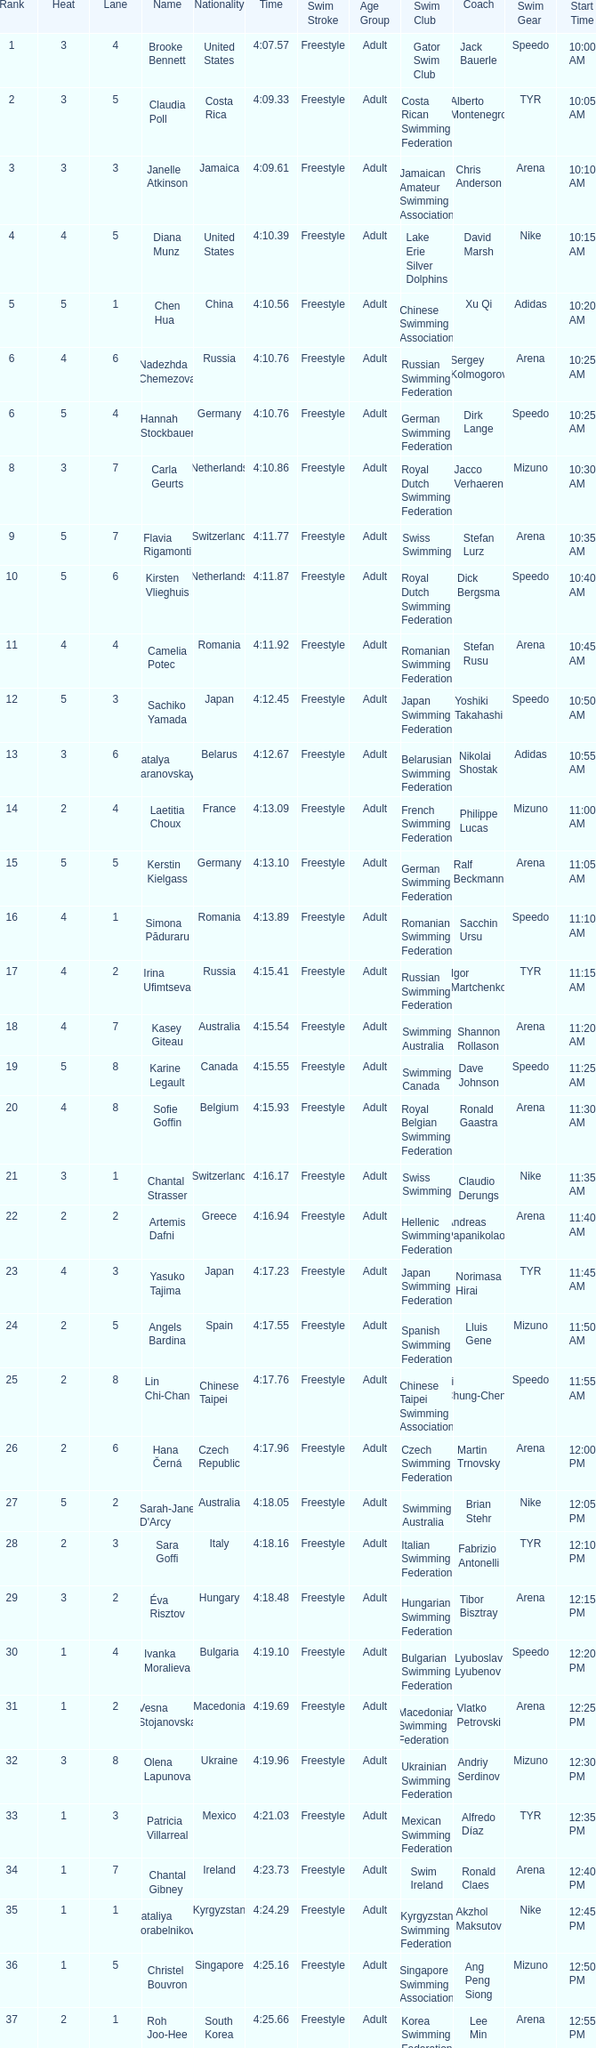Name the least lane for kasey giteau and rank less than 18 None. 